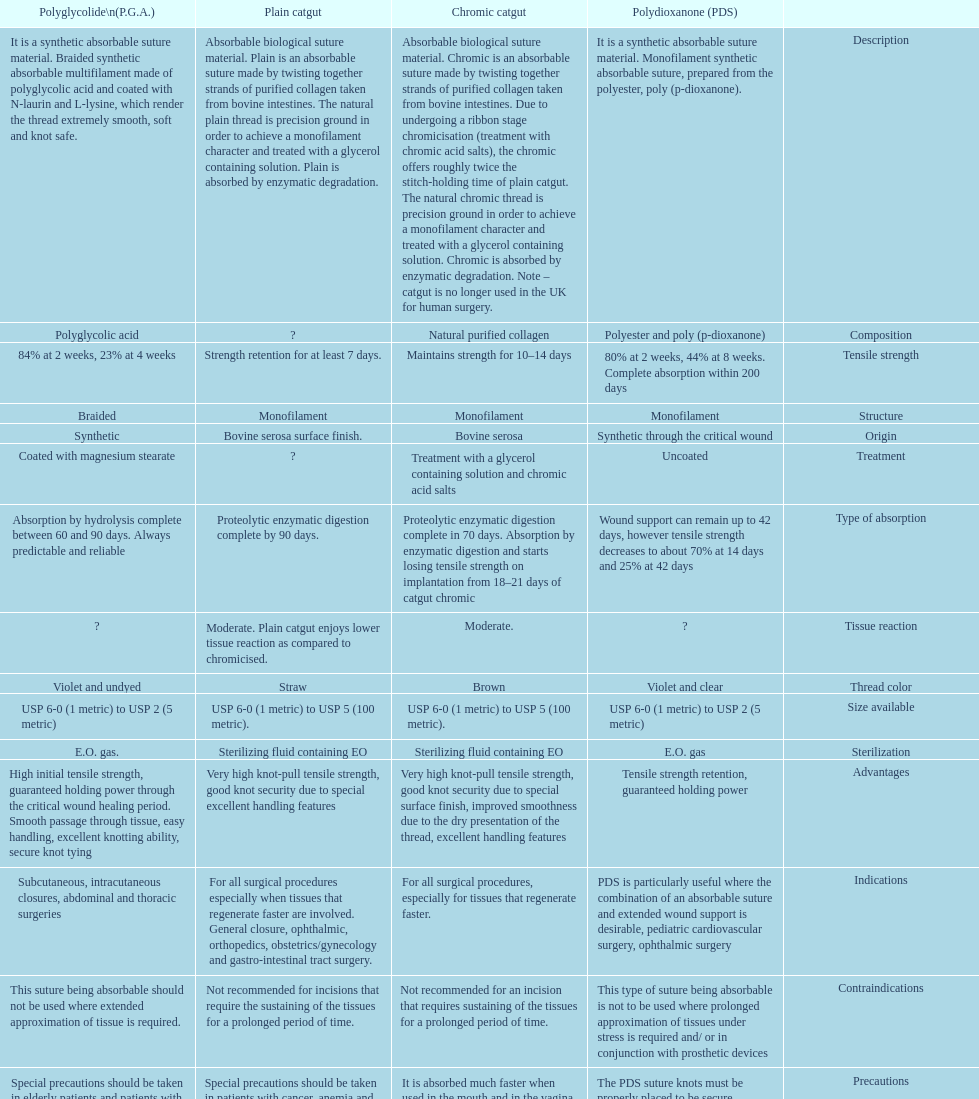How long does a chromic catgut maintain it's strength for 10-14 days. 